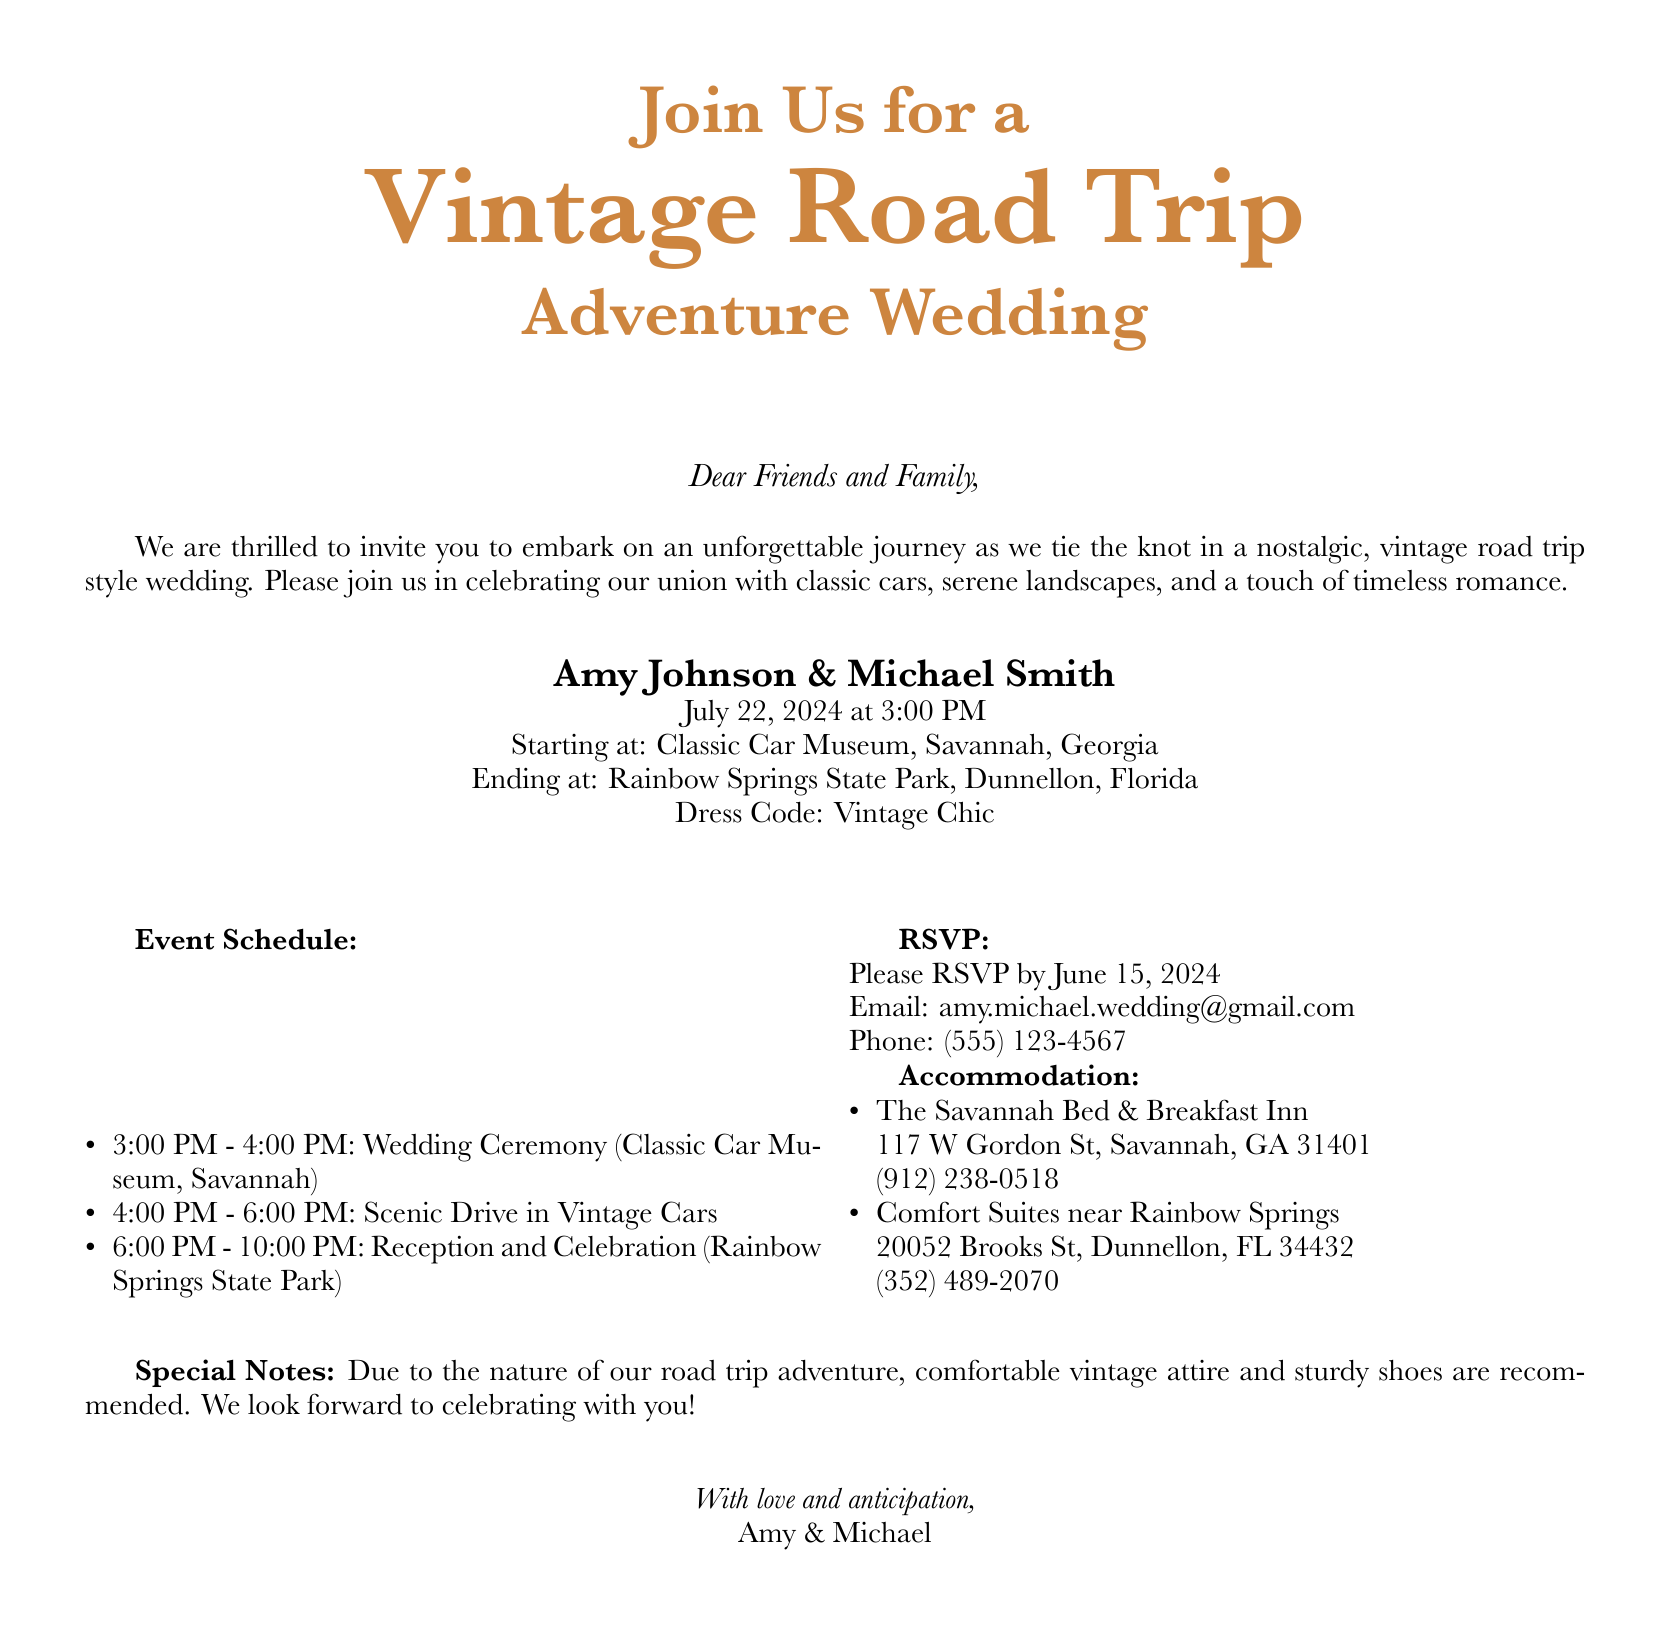What is the date of the wedding? The document specifies that the wedding will take place on July 22, 2024.
Answer: July 22, 2024 Who are the couple getting married? The wedding invitation lists Amy Johnson and Michael Smith as the couple getting married.
Answer: Amy Johnson & Michael Smith What is the starting location of the wedding ceremony? The document indicates that the ceremony will start at the Classic Car Museum in Savannah, Georgia.
Answer: Classic Car Museum, Savannah, Georgia What time does the reception begin? According to the schedule in the document, the reception starts at 6:00 PM.
Answer: 6:00 PM What is the dress code for the wedding? The invitation outlines that the dress code for the event is Vintage Chic.
Answer: Vintage Chic How should guests prepare for the adventure? The document suggests that comfortable vintage attire and sturdy shoes are recommended for guests due to the nature of the road trip.
Answer: Comfortable vintage attire and sturdy shoes When is the RSVP deadline? The wedding invitation states that RSVPs should be submitted by June 15, 2024.
Answer: June 15, 2024 What is the email to send RSVPs? The document provides the email address for RSVPs as amy.michael.wedding@gmail.com.
Answer: amy.michael.wedding@gmail.com What is the accommodation option in Savannah? The invitation lists The Savannah Bed & Breakfast Inn as one of the accommodation options.
Answer: The Savannah Bed & Breakfast Inn 